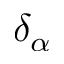Convert formula to latex. <formula><loc_0><loc_0><loc_500><loc_500>\delta _ { \alpha }</formula> 